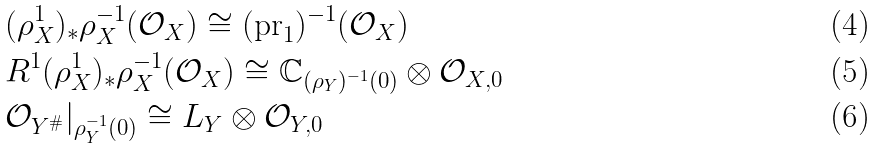Convert formula to latex. <formula><loc_0><loc_0><loc_500><loc_500>& ( \rho _ { X } ^ { 1 } ) _ { * } \rho _ { X } ^ { - 1 } ( \mathcal { O } _ { X } ) \cong ( \text {pr} _ { 1 } ) ^ { - 1 } ( \mathcal { O } _ { X } ) \\ & R ^ { 1 } ( \rho _ { X } ^ { 1 } ) _ { * } \rho _ { X } ^ { - 1 } ( \mathcal { O } _ { X } ) \cong \mathbb { C } _ { ( \rho _ { Y } ) ^ { - 1 } ( 0 ) } \otimes \mathcal { O } _ { X , 0 } \\ & \mathcal { O } _ { Y ^ { \# } } | _ { \rho _ { Y } ^ { - 1 } ( 0 ) } \cong L _ { Y } \otimes \mathcal { O } _ { Y , 0 }</formula> 